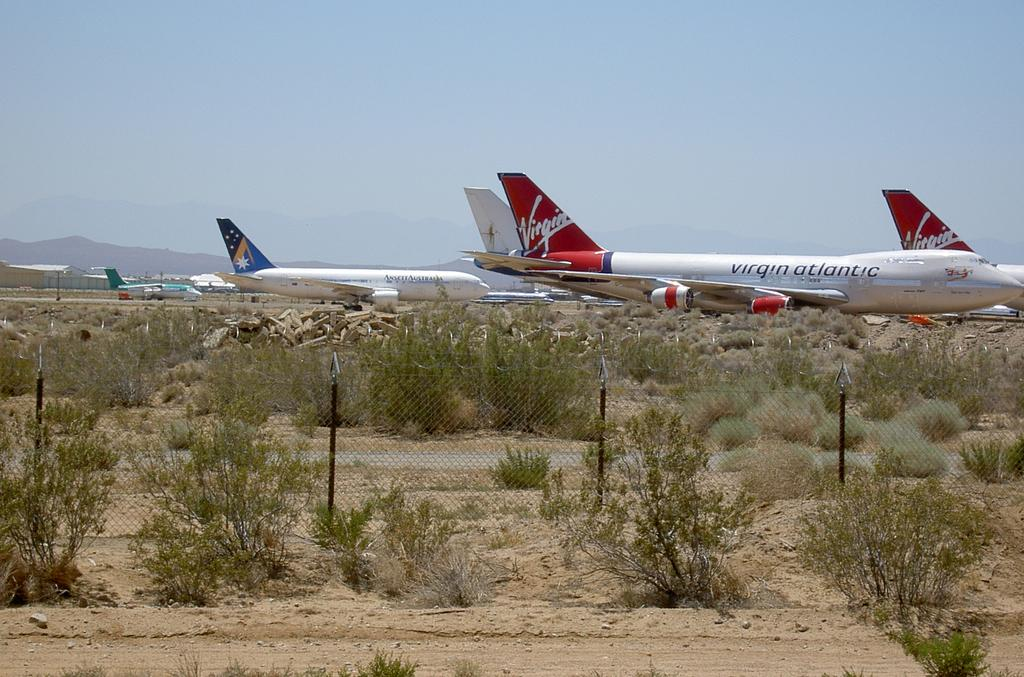<image>
Share a concise interpretation of the image provided. A Virgin Atlantic plane is parked near a couple other planes. 